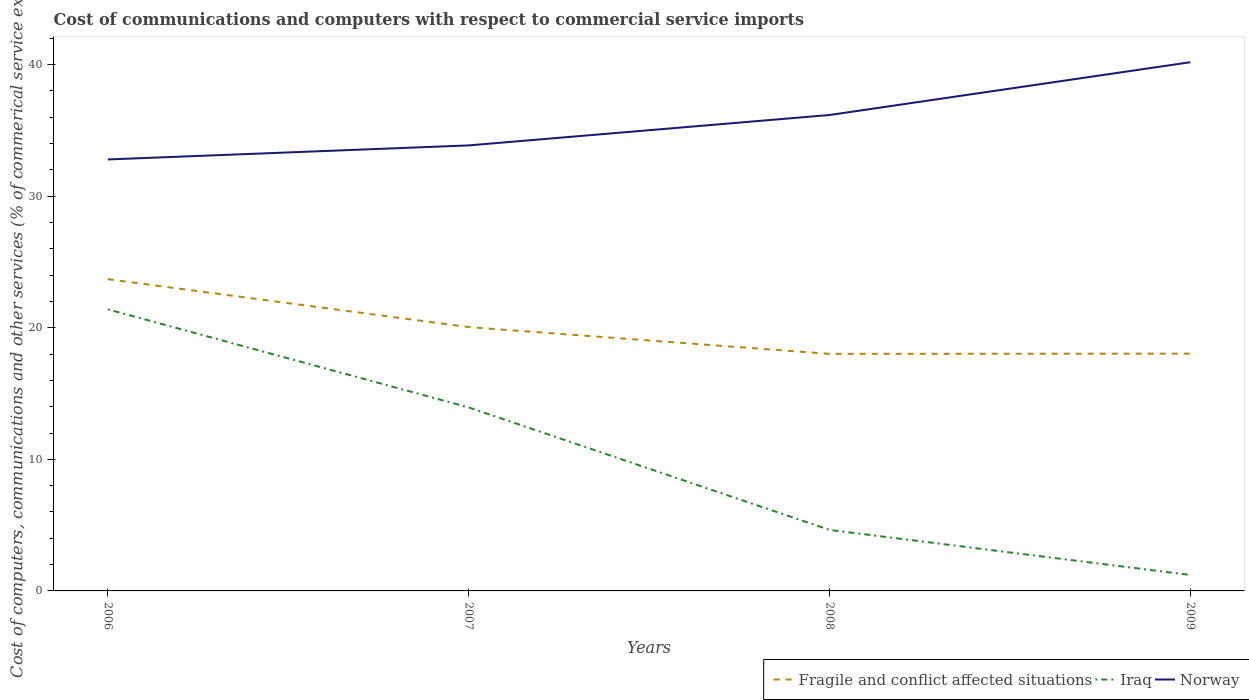How many different coloured lines are there?
Your response must be concise. 3. Is the number of lines equal to the number of legend labels?
Your answer should be compact. Yes. Across all years, what is the maximum cost of communications and computers in Fragile and conflict affected situations?
Offer a terse response. 18.01. In which year was the cost of communications and computers in Iraq maximum?
Offer a very short reply. 2009. What is the total cost of communications and computers in Fragile and conflict affected situations in the graph?
Your answer should be very brief. 3.64. What is the difference between the highest and the second highest cost of communications and computers in Fragile and conflict affected situations?
Offer a very short reply. 5.67. How many lines are there?
Offer a very short reply. 3. Does the graph contain any zero values?
Your answer should be very brief. No. What is the title of the graph?
Ensure brevity in your answer.  Cost of communications and computers with respect to commercial service imports. Does "Syrian Arab Republic" appear as one of the legend labels in the graph?
Your response must be concise. No. What is the label or title of the X-axis?
Provide a short and direct response. Years. What is the label or title of the Y-axis?
Offer a terse response. Cost of computers, communications and other services (% of commerical service exports). What is the Cost of computers, communications and other services (% of commerical service exports) of Fragile and conflict affected situations in 2006?
Give a very brief answer. 23.69. What is the Cost of computers, communications and other services (% of commerical service exports) in Iraq in 2006?
Offer a very short reply. 21.4. What is the Cost of computers, communications and other services (% of commerical service exports) of Norway in 2006?
Provide a succinct answer. 32.79. What is the Cost of computers, communications and other services (% of commerical service exports) of Fragile and conflict affected situations in 2007?
Offer a terse response. 20.05. What is the Cost of computers, communications and other services (% of commerical service exports) of Iraq in 2007?
Keep it short and to the point. 13.95. What is the Cost of computers, communications and other services (% of commerical service exports) in Norway in 2007?
Make the answer very short. 33.86. What is the Cost of computers, communications and other services (% of commerical service exports) of Fragile and conflict affected situations in 2008?
Offer a very short reply. 18.01. What is the Cost of computers, communications and other services (% of commerical service exports) in Iraq in 2008?
Keep it short and to the point. 4.64. What is the Cost of computers, communications and other services (% of commerical service exports) of Norway in 2008?
Provide a short and direct response. 36.17. What is the Cost of computers, communications and other services (% of commerical service exports) in Fragile and conflict affected situations in 2009?
Your response must be concise. 18.03. What is the Cost of computers, communications and other services (% of commerical service exports) of Iraq in 2009?
Your answer should be compact. 1.21. What is the Cost of computers, communications and other services (% of commerical service exports) in Norway in 2009?
Offer a very short reply. 40.18. Across all years, what is the maximum Cost of computers, communications and other services (% of commerical service exports) of Fragile and conflict affected situations?
Your answer should be very brief. 23.69. Across all years, what is the maximum Cost of computers, communications and other services (% of commerical service exports) in Iraq?
Keep it short and to the point. 21.4. Across all years, what is the maximum Cost of computers, communications and other services (% of commerical service exports) of Norway?
Ensure brevity in your answer.  40.18. Across all years, what is the minimum Cost of computers, communications and other services (% of commerical service exports) in Fragile and conflict affected situations?
Make the answer very short. 18.01. Across all years, what is the minimum Cost of computers, communications and other services (% of commerical service exports) in Iraq?
Make the answer very short. 1.21. Across all years, what is the minimum Cost of computers, communications and other services (% of commerical service exports) in Norway?
Your response must be concise. 32.79. What is the total Cost of computers, communications and other services (% of commerical service exports) of Fragile and conflict affected situations in the graph?
Provide a short and direct response. 79.78. What is the total Cost of computers, communications and other services (% of commerical service exports) of Iraq in the graph?
Give a very brief answer. 41.19. What is the total Cost of computers, communications and other services (% of commerical service exports) of Norway in the graph?
Provide a short and direct response. 142.98. What is the difference between the Cost of computers, communications and other services (% of commerical service exports) of Fragile and conflict affected situations in 2006 and that in 2007?
Provide a short and direct response. 3.64. What is the difference between the Cost of computers, communications and other services (% of commerical service exports) of Iraq in 2006 and that in 2007?
Provide a short and direct response. 7.45. What is the difference between the Cost of computers, communications and other services (% of commerical service exports) of Norway in 2006 and that in 2007?
Make the answer very short. -1.07. What is the difference between the Cost of computers, communications and other services (% of commerical service exports) in Fragile and conflict affected situations in 2006 and that in 2008?
Ensure brevity in your answer.  5.67. What is the difference between the Cost of computers, communications and other services (% of commerical service exports) of Iraq in 2006 and that in 2008?
Ensure brevity in your answer.  16.76. What is the difference between the Cost of computers, communications and other services (% of commerical service exports) of Norway in 2006 and that in 2008?
Provide a short and direct response. -3.38. What is the difference between the Cost of computers, communications and other services (% of commerical service exports) in Fragile and conflict affected situations in 2006 and that in 2009?
Offer a terse response. 5.66. What is the difference between the Cost of computers, communications and other services (% of commerical service exports) in Iraq in 2006 and that in 2009?
Give a very brief answer. 20.19. What is the difference between the Cost of computers, communications and other services (% of commerical service exports) in Norway in 2006 and that in 2009?
Provide a short and direct response. -7.39. What is the difference between the Cost of computers, communications and other services (% of commerical service exports) of Fragile and conflict affected situations in 2007 and that in 2008?
Ensure brevity in your answer.  2.03. What is the difference between the Cost of computers, communications and other services (% of commerical service exports) of Iraq in 2007 and that in 2008?
Offer a terse response. 9.31. What is the difference between the Cost of computers, communications and other services (% of commerical service exports) of Norway in 2007 and that in 2008?
Your answer should be very brief. -2.31. What is the difference between the Cost of computers, communications and other services (% of commerical service exports) in Fragile and conflict affected situations in 2007 and that in 2009?
Provide a short and direct response. 2.02. What is the difference between the Cost of computers, communications and other services (% of commerical service exports) in Iraq in 2007 and that in 2009?
Keep it short and to the point. 12.73. What is the difference between the Cost of computers, communications and other services (% of commerical service exports) of Norway in 2007 and that in 2009?
Your answer should be very brief. -6.32. What is the difference between the Cost of computers, communications and other services (% of commerical service exports) of Fragile and conflict affected situations in 2008 and that in 2009?
Offer a terse response. -0.02. What is the difference between the Cost of computers, communications and other services (% of commerical service exports) of Iraq in 2008 and that in 2009?
Ensure brevity in your answer.  3.42. What is the difference between the Cost of computers, communications and other services (% of commerical service exports) of Norway in 2008 and that in 2009?
Provide a succinct answer. -4.01. What is the difference between the Cost of computers, communications and other services (% of commerical service exports) in Fragile and conflict affected situations in 2006 and the Cost of computers, communications and other services (% of commerical service exports) in Iraq in 2007?
Provide a succinct answer. 9.74. What is the difference between the Cost of computers, communications and other services (% of commerical service exports) of Fragile and conflict affected situations in 2006 and the Cost of computers, communications and other services (% of commerical service exports) of Norway in 2007?
Give a very brief answer. -10.17. What is the difference between the Cost of computers, communications and other services (% of commerical service exports) of Iraq in 2006 and the Cost of computers, communications and other services (% of commerical service exports) of Norway in 2007?
Provide a succinct answer. -12.46. What is the difference between the Cost of computers, communications and other services (% of commerical service exports) in Fragile and conflict affected situations in 2006 and the Cost of computers, communications and other services (% of commerical service exports) in Iraq in 2008?
Provide a succinct answer. 19.05. What is the difference between the Cost of computers, communications and other services (% of commerical service exports) in Fragile and conflict affected situations in 2006 and the Cost of computers, communications and other services (% of commerical service exports) in Norway in 2008?
Give a very brief answer. -12.48. What is the difference between the Cost of computers, communications and other services (% of commerical service exports) of Iraq in 2006 and the Cost of computers, communications and other services (% of commerical service exports) of Norway in 2008?
Keep it short and to the point. -14.77. What is the difference between the Cost of computers, communications and other services (% of commerical service exports) in Fragile and conflict affected situations in 2006 and the Cost of computers, communications and other services (% of commerical service exports) in Iraq in 2009?
Make the answer very short. 22.48. What is the difference between the Cost of computers, communications and other services (% of commerical service exports) of Fragile and conflict affected situations in 2006 and the Cost of computers, communications and other services (% of commerical service exports) of Norway in 2009?
Provide a succinct answer. -16.49. What is the difference between the Cost of computers, communications and other services (% of commerical service exports) of Iraq in 2006 and the Cost of computers, communications and other services (% of commerical service exports) of Norway in 2009?
Provide a short and direct response. -18.78. What is the difference between the Cost of computers, communications and other services (% of commerical service exports) in Fragile and conflict affected situations in 2007 and the Cost of computers, communications and other services (% of commerical service exports) in Iraq in 2008?
Keep it short and to the point. 15.41. What is the difference between the Cost of computers, communications and other services (% of commerical service exports) in Fragile and conflict affected situations in 2007 and the Cost of computers, communications and other services (% of commerical service exports) in Norway in 2008?
Your response must be concise. -16.12. What is the difference between the Cost of computers, communications and other services (% of commerical service exports) of Iraq in 2007 and the Cost of computers, communications and other services (% of commerical service exports) of Norway in 2008?
Keep it short and to the point. -22.22. What is the difference between the Cost of computers, communications and other services (% of commerical service exports) in Fragile and conflict affected situations in 2007 and the Cost of computers, communications and other services (% of commerical service exports) in Iraq in 2009?
Ensure brevity in your answer.  18.84. What is the difference between the Cost of computers, communications and other services (% of commerical service exports) in Fragile and conflict affected situations in 2007 and the Cost of computers, communications and other services (% of commerical service exports) in Norway in 2009?
Your response must be concise. -20.13. What is the difference between the Cost of computers, communications and other services (% of commerical service exports) of Iraq in 2007 and the Cost of computers, communications and other services (% of commerical service exports) of Norway in 2009?
Give a very brief answer. -26.23. What is the difference between the Cost of computers, communications and other services (% of commerical service exports) of Fragile and conflict affected situations in 2008 and the Cost of computers, communications and other services (% of commerical service exports) of Iraq in 2009?
Give a very brief answer. 16.8. What is the difference between the Cost of computers, communications and other services (% of commerical service exports) of Fragile and conflict affected situations in 2008 and the Cost of computers, communications and other services (% of commerical service exports) of Norway in 2009?
Keep it short and to the point. -22.16. What is the difference between the Cost of computers, communications and other services (% of commerical service exports) of Iraq in 2008 and the Cost of computers, communications and other services (% of commerical service exports) of Norway in 2009?
Keep it short and to the point. -35.54. What is the average Cost of computers, communications and other services (% of commerical service exports) in Fragile and conflict affected situations per year?
Offer a very short reply. 19.95. What is the average Cost of computers, communications and other services (% of commerical service exports) in Iraq per year?
Your response must be concise. 10.3. What is the average Cost of computers, communications and other services (% of commerical service exports) of Norway per year?
Offer a very short reply. 35.75. In the year 2006, what is the difference between the Cost of computers, communications and other services (% of commerical service exports) of Fragile and conflict affected situations and Cost of computers, communications and other services (% of commerical service exports) of Iraq?
Your response must be concise. 2.29. In the year 2006, what is the difference between the Cost of computers, communications and other services (% of commerical service exports) of Fragile and conflict affected situations and Cost of computers, communications and other services (% of commerical service exports) of Norway?
Give a very brief answer. -9.1. In the year 2006, what is the difference between the Cost of computers, communications and other services (% of commerical service exports) of Iraq and Cost of computers, communications and other services (% of commerical service exports) of Norway?
Your answer should be compact. -11.39. In the year 2007, what is the difference between the Cost of computers, communications and other services (% of commerical service exports) in Fragile and conflict affected situations and Cost of computers, communications and other services (% of commerical service exports) in Iraq?
Make the answer very short. 6.1. In the year 2007, what is the difference between the Cost of computers, communications and other services (% of commerical service exports) in Fragile and conflict affected situations and Cost of computers, communications and other services (% of commerical service exports) in Norway?
Provide a succinct answer. -13.81. In the year 2007, what is the difference between the Cost of computers, communications and other services (% of commerical service exports) of Iraq and Cost of computers, communications and other services (% of commerical service exports) of Norway?
Offer a terse response. -19.91. In the year 2008, what is the difference between the Cost of computers, communications and other services (% of commerical service exports) of Fragile and conflict affected situations and Cost of computers, communications and other services (% of commerical service exports) of Iraq?
Ensure brevity in your answer.  13.38. In the year 2008, what is the difference between the Cost of computers, communications and other services (% of commerical service exports) in Fragile and conflict affected situations and Cost of computers, communications and other services (% of commerical service exports) in Norway?
Your answer should be compact. -18.15. In the year 2008, what is the difference between the Cost of computers, communications and other services (% of commerical service exports) of Iraq and Cost of computers, communications and other services (% of commerical service exports) of Norway?
Make the answer very short. -31.53. In the year 2009, what is the difference between the Cost of computers, communications and other services (% of commerical service exports) in Fragile and conflict affected situations and Cost of computers, communications and other services (% of commerical service exports) in Iraq?
Your answer should be very brief. 16.82. In the year 2009, what is the difference between the Cost of computers, communications and other services (% of commerical service exports) of Fragile and conflict affected situations and Cost of computers, communications and other services (% of commerical service exports) of Norway?
Your answer should be compact. -22.15. In the year 2009, what is the difference between the Cost of computers, communications and other services (% of commerical service exports) in Iraq and Cost of computers, communications and other services (% of commerical service exports) in Norway?
Provide a succinct answer. -38.96. What is the ratio of the Cost of computers, communications and other services (% of commerical service exports) of Fragile and conflict affected situations in 2006 to that in 2007?
Keep it short and to the point. 1.18. What is the ratio of the Cost of computers, communications and other services (% of commerical service exports) of Iraq in 2006 to that in 2007?
Provide a succinct answer. 1.53. What is the ratio of the Cost of computers, communications and other services (% of commerical service exports) in Norway in 2006 to that in 2007?
Keep it short and to the point. 0.97. What is the ratio of the Cost of computers, communications and other services (% of commerical service exports) in Fragile and conflict affected situations in 2006 to that in 2008?
Keep it short and to the point. 1.31. What is the ratio of the Cost of computers, communications and other services (% of commerical service exports) in Iraq in 2006 to that in 2008?
Make the answer very short. 4.62. What is the ratio of the Cost of computers, communications and other services (% of commerical service exports) of Norway in 2006 to that in 2008?
Your response must be concise. 0.91. What is the ratio of the Cost of computers, communications and other services (% of commerical service exports) of Fragile and conflict affected situations in 2006 to that in 2009?
Keep it short and to the point. 1.31. What is the ratio of the Cost of computers, communications and other services (% of commerical service exports) in Iraq in 2006 to that in 2009?
Provide a short and direct response. 17.64. What is the ratio of the Cost of computers, communications and other services (% of commerical service exports) in Norway in 2006 to that in 2009?
Make the answer very short. 0.82. What is the ratio of the Cost of computers, communications and other services (% of commerical service exports) of Fragile and conflict affected situations in 2007 to that in 2008?
Ensure brevity in your answer.  1.11. What is the ratio of the Cost of computers, communications and other services (% of commerical service exports) of Iraq in 2007 to that in 2008?
Offer a terse response. 3.01. What is the ratio of the Cost of computers, communications and other services (% of commerical service exports) in Norway in 2007 to that in 2008?
Your answer should be compact. 0.94. What is the ratio of the Cost of computers, communications and other services (% of commerical service exports) of Fragile and conflict affected situations in 2007 to that in 2009?
Provide a succinct answer. 1.11. What is the ratio of the Cost of computers, communications and other services (% of commerical service exports) in Iraq in 2007 to that in 2009?
Ensure brevity in your answer.  11.5. What is the ratio of the Cost of computers, communications and other services (% of commerical service exports) in Norway in 2007 to that in 2009?
Ensure brevity in your answer.  0.84. What is the ratio of the Cost of computers, communications and other services (% of commerical service exports) in Fragile and conflict affected situations in 2008 to that in 2009?
Keep it short and to the point. 1. What is the ratio of the Cost of computers, communications and other services (% of commerical service exports) of Iraq in 2008 to that in 2009?
Your answer should be compact. 3.82. What is the ratio of the Cost of computers, communications and other services (% of commerical service exports) in Norway in 2008 to that in 2009?
Offer a terse response. 0.9. What is the difference between the highest and the second highest Cost of computers, communications and other services (% of commerical service exports) in Fragile and conflict affected situations?
Your response must be concise. 3.64. What is the difference between the highest and the second highest Cost of computers, communications and other services (% of commerical service exports) in Iraq?
Provide a succinct answer. 7.45. What is the difference between the highest and the second highest Cost of computers, communications and other services (% of commerical service exports) of Norway?
Your response must be concise. 4.01. What is the difference between the highest and the lowest Cost of computers, communications and other services (% of commerical service exports) in Fragile and conflict affected situations?
Your answer should be very brief. 5.67. What is the difference between the highest and the lowest Cost of computers, communications and other services (% of commerical service exports) in Iraq?
Make the answer very short. 20.19. What is the difference between the highest and the lowest Cost of computers, communications and other services (% of commerical service exports) in Norway?
Your answer should be compact. 7.39. 